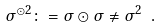<formula> <loc_0><loc_0><loc_500><loc_500>\sigma ^ { \odot 2 } \colon = \sigma \odot \sigma \ne \sigma ^ { 2 } \ .</formula> 